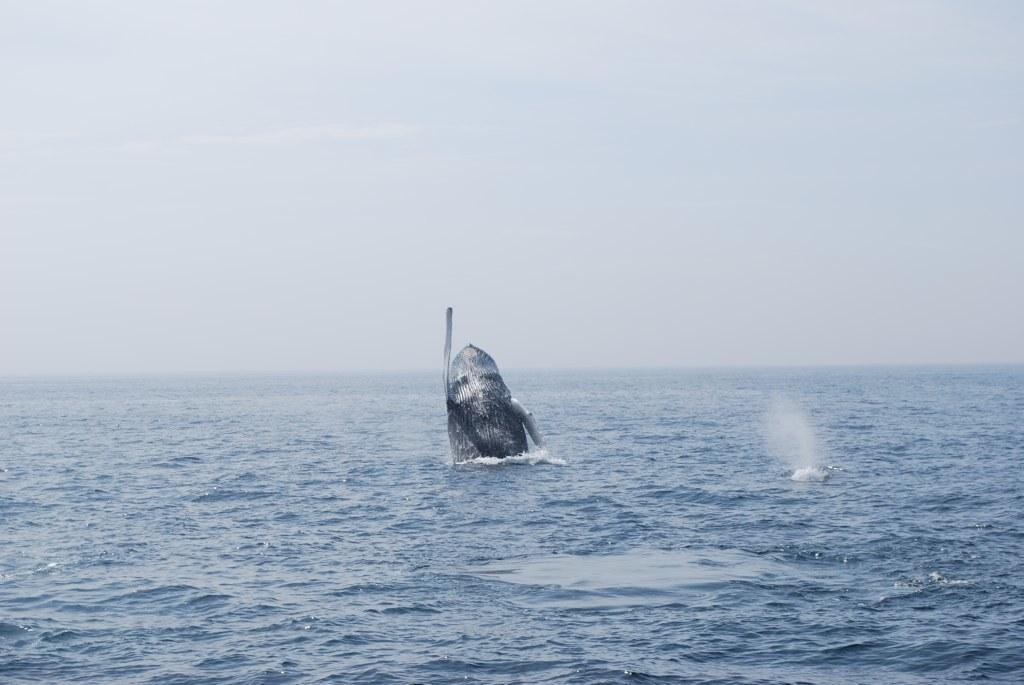What is the main subject of the image? The main subject of the image is a whale. What is the whale doing in the image? The whale is coming out of the water in the image. What can be seen in the background of the image? The sky is visible in the background of the image. How would you describe the weather based on the sky in the image? The sky appears to be cloudy in the image, suggesting a potentially overcast or rainy day. Where is the basket located in the image? There is no basket present in the image. Is the boy riding the whale in the image? There is no boy present in the image, so it is impossible for him to be riding the whale. 